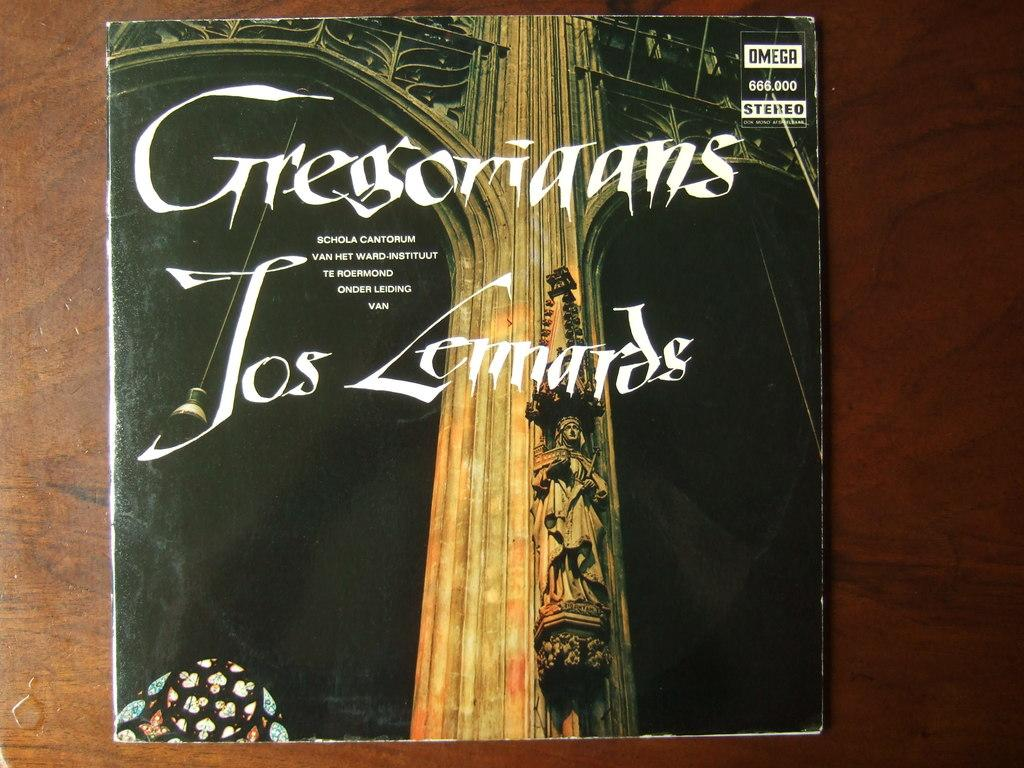<image>
Describe the image concisely. The record album is called Gregoriaans Los Lennards 